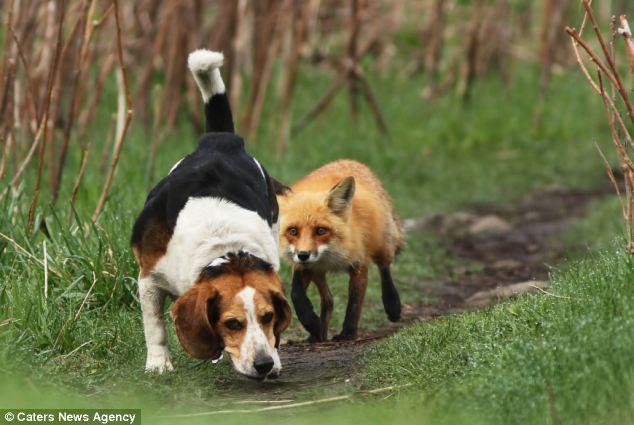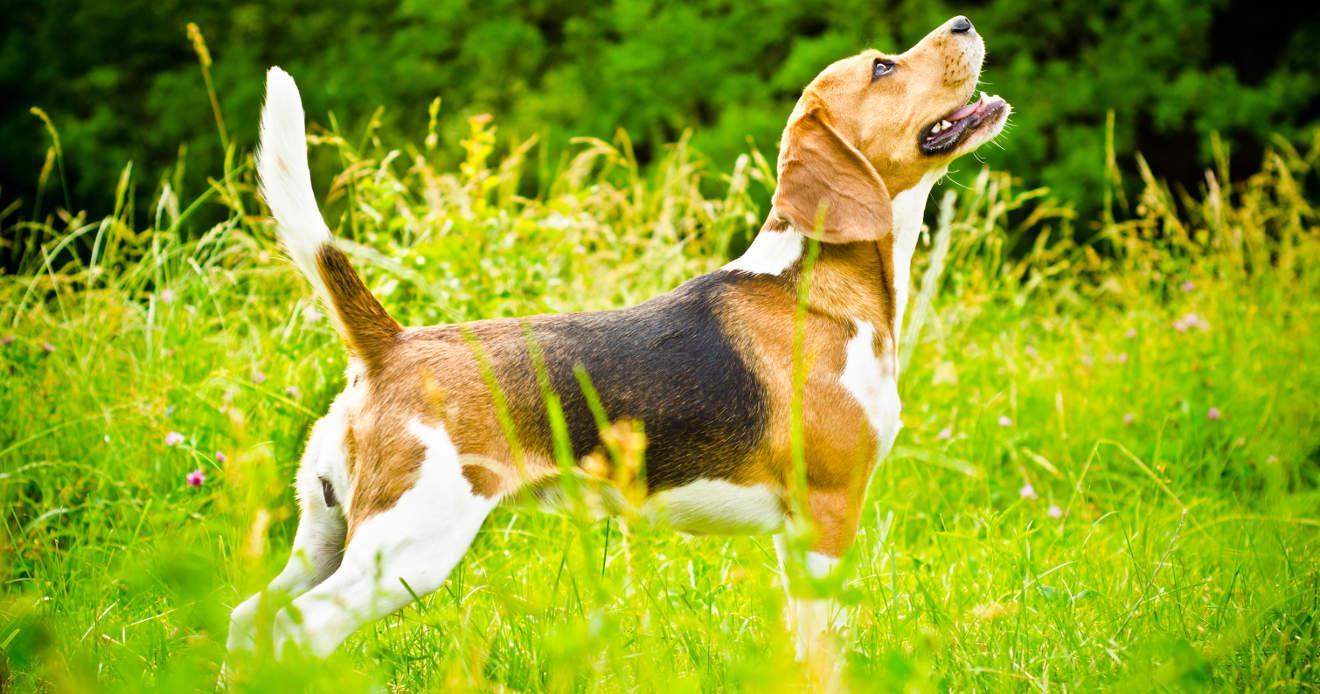The first image is the image on the left, the second image is the image on the right. Given the left and right images, does the statement "There is a single dog lying in the grass in the image on the right." hold true? Answer yes or no. No. 